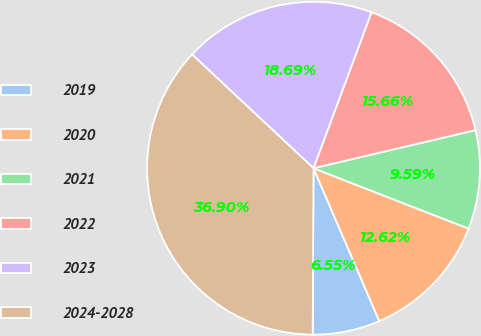Convert chart. <chart><loc_0><loc_0><loc_500><loc_500><pie_chart><fcel>2019<fcel>2020<fcel>2021<fcel>2022<fcel>2023<fcel>2024-2028<nl><fcel>6.55%<fcel>12.62%<fcel>9.59%<fcel>15.66%<fcel>18.69%<fcel>36.9%<nl></chart> 